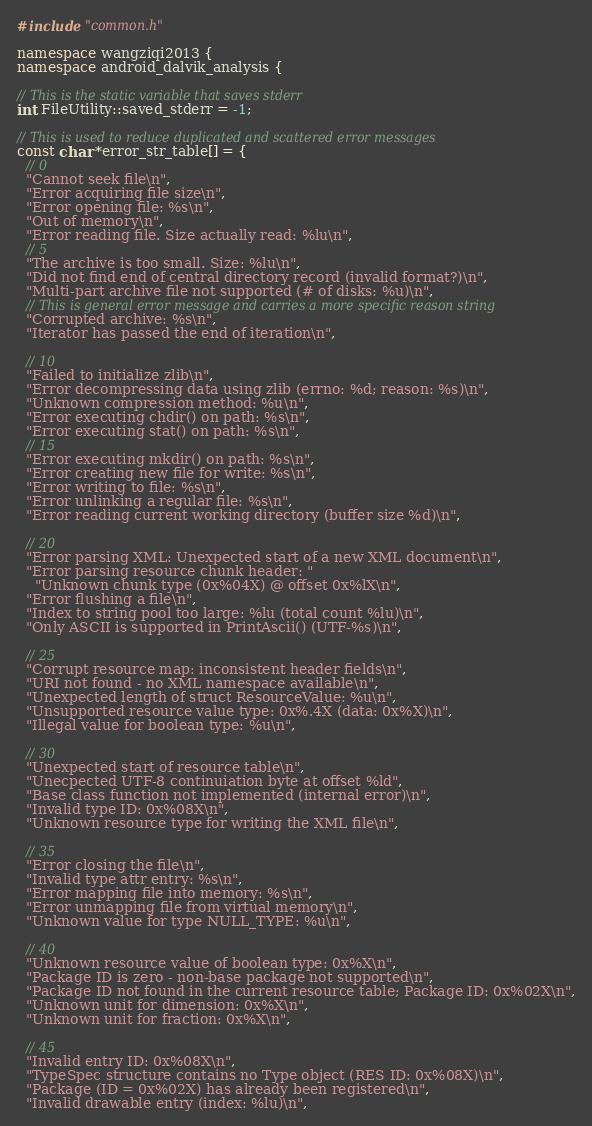<code> <loc_0><loc_0><loc_500><loc_500><_C++_>
#include "common.h"

namespace wangziqi2013 {
namespace android_dalvik_analysis {

// This is the static variable that saves stderr
int FileUtility::saved_stderr = -1;

// This is used to reduce duplicated and scattered error messages
const char *error_str_table[] = {
  // 0
  "Cannot seek file\n",
  "Error acquiring file size\n",
  "Error opening file: %s\n",
  "Out of memory\n",
  "Error reading file. Size actually read: %lu\n",
  // 5
  "The archive is too small. Size: %lu\n",
  "Did not find end of central directory record (invalid format?)\n",
  "Multi-part archive file not supported (# of disks: %u)\n",
  // This is general error message and carries a more specific reason string
  "Corrupted archive: %s\n", 
  "Iterator has passed the end of iteration\n",
  
  // 10
  "Failed to initialize zlib\n",
  "Error decompressing data using zlib (errno: %d; reason: %s)\n",
  "Unknown compression method: %u\n",
  "Error executing chdir() on path: %s\n",
  "Error executing stat() on path: %s\n",
  // 15
  "Error executing mkdir() on path: %s\n",
  "Error creating new file for write: %s\n",
  "Error writing to file: %s\n",
  "Error unlinking a regular file: %s\n",
  "Error reading current working directory (buffer size %d)\n",
  
  // 20
  "Error parsing XML: Unexpected start of a new XML document\n",
  "Error parsing resource chunk header: "
    "Unknown chunk type (0x%04X) @ offset 0x%lX\n",
  "Error flushing a file\n",
  "Index to string pool too large: %lu (total count %lu)\n",
  "Only ASCII is supported in PrintAscii() (UTF-%s)\n",
  
  // 25
  "Corrupt resource map: inconsistent header fields\n",
  "URI not found - no XML namespace available\n",
  "Unexpected length of struct ResourceValue: %u\n",
  "Unsupported resource value type: 0x%.4X (data: 0x%X)\n",
  "Illegal value for boolean type: %u\n",
  
  // 30
  "Unexpected start of resource table\n",
  "Unecpected UTF-8 continuiation byte at offset %ld", 
  "Base class function not implemented (internal error)\n",
  "Invalid type ID: 0x%08X\n",
  "Unknown resource type for writing the XML file\n",
  
  // 35
  "Error closing the file\n",
  "Invalid type attr entry: %s\n",
  "Error mapping file into memory: %s\n",
  "Error unmapping file from virtual memory\n",
  "Unknown value for type NULL_TYPE: %u\n",
  
  // 40
  "Unknown resource value of boolean type: 0x%X\n",
  "Package ID is zero - non-base package not supported\n",
  "Package ID not found in the current resource table; Package ID: 0x%02X\n",
  "Unknown unit for dimension: 0x%X\n",
  "Unknown unit for fraction: 0x%X\n",
  
  // 45
  "Invalid entry ID: 0x%08X\n",
  "TypeSpec structure contains no Type object (RES ID: 0x%08X)\n",
  "Package (ID = 0x%02X) has already been registered\n",
  "Invalid drawable entry (index: %lu)\n",</code> 